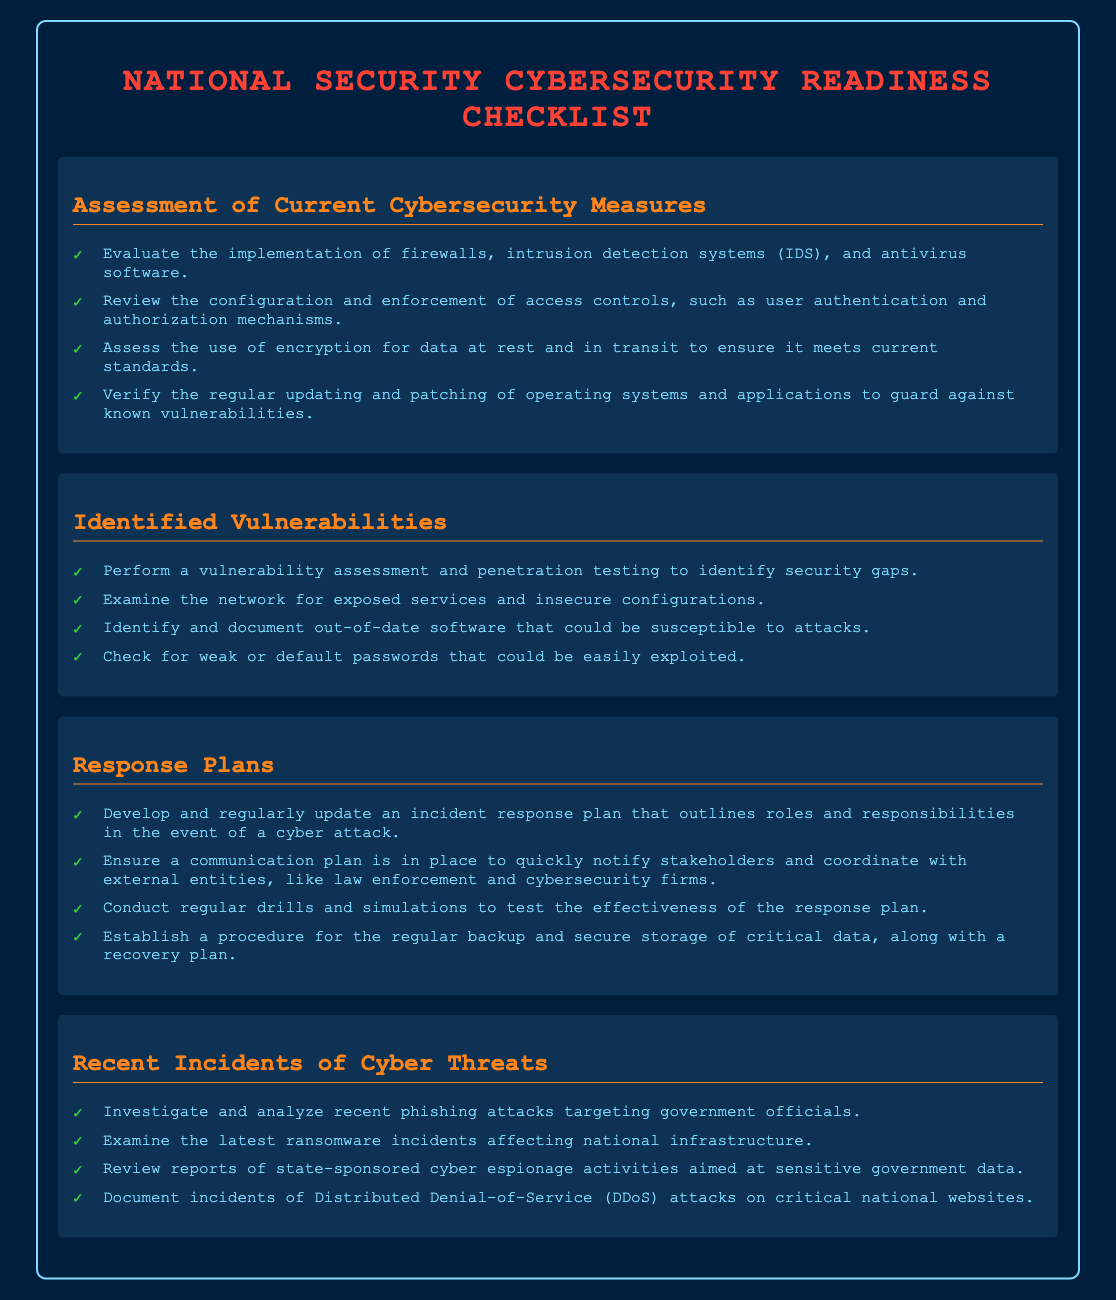what are the components evaluated in the assessment of current cybersecurity measures? The assessment evaluates firewalls, intrusion detection systems, and antivirus software implementation.
Answer: firewalls, intrusion detection systems, antivirus software how often should the incident response plan be updated? The document implies that the incident response plan should be regularly updated.
Answer: regularly what type of testing is performed to identify vulnerabilities? The document mentions vulnerability assessment and penetration testing as methods to identify security gaps.
Answer: vulnerability assessment and penetration testing what is one requirement for the response plan besides incident handling? A communication plan must be in place to notify stakeholders and coordinate with external entities.
Answer: communication plan which recent cyber threat is mentioned related to national infrastructure? The document refers to recent ransomware incidents affecting national infrastructure.
Answer: ransomware incidents how are weak passwords addressed in identified vulnerabilities? The checklist states the importance of checking for weak or default passwords that could be exploited.
Answer: weak or default passwords how many sections are included in the checklist? The document contains four sections covering different aspects of cybersecurity readiness.
Answer: four what type of attacks are investigated concerning government officials? The document discusses investigating recent phishing attacks targeting government officials.
Answer: phishing attacks what is established for backing up critical data? A procedure for regular backup and secure storage of critical data is established, along with a recovery plan.
Answer: backup and secure storage procedure 